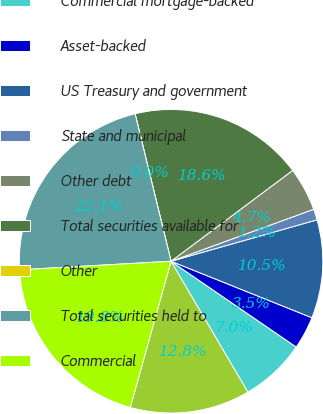Convert chart. <chart><loc_0><loc_0><loc_500><loc_500><pie_chart><fcel>Non-agency<fcel>Commercial mortgage-backed<fcel>Asset-backed<fcel>US Treasury and government<fcel>State and municipal<fcel>Other debt<fcel>Total securities available for<fcel>Other<fcel>Total securities held to<fcel>Commercial<nl><fcel>12.79%<fcel>6.98%<fcel>3.49%<fcel>10.47%<fcel>1.16%<fcel>4.65%<fcel>18.6%<fcel>0.0%<fcel>22.09%<fcel>19.77%<nl></chart> 